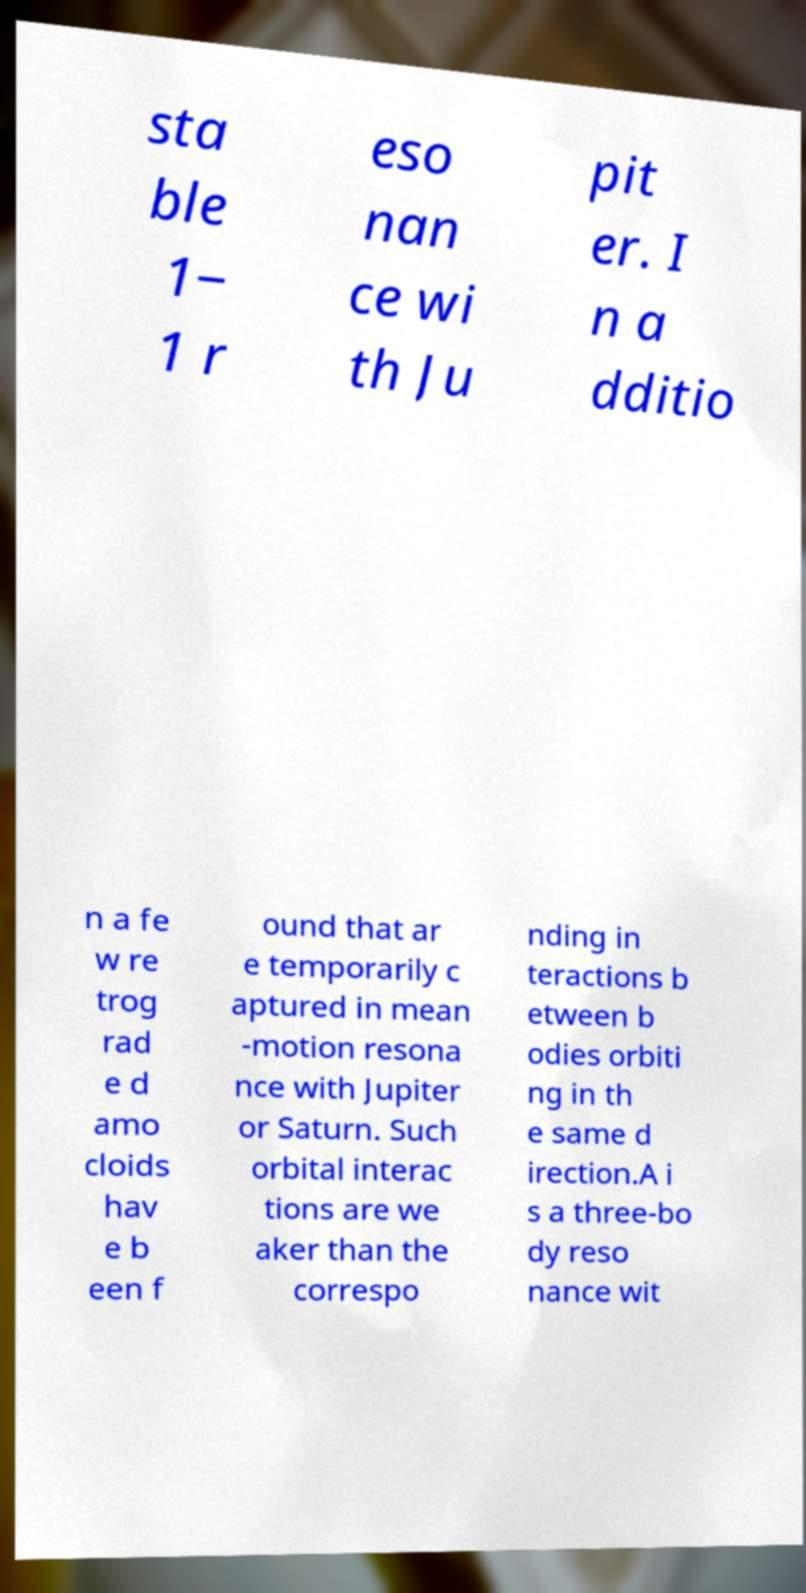For documentation purposes, I need the text within this image transcribed. Could you provide that? sta ble 1− 1 r eso nan ce wi th Ju pit er. I n a dditio n a fe w re trog rad e d amo cloids hav e b een f ound that ar e temporarily c aptured in mean -motion resona nce with Jupiter or Saturn. Such orbital interac tions are we aker than the correspo nding in teractions b etween b odies orbiti ng in th e same d irection.A i s a three-bo dy reso nance wit 